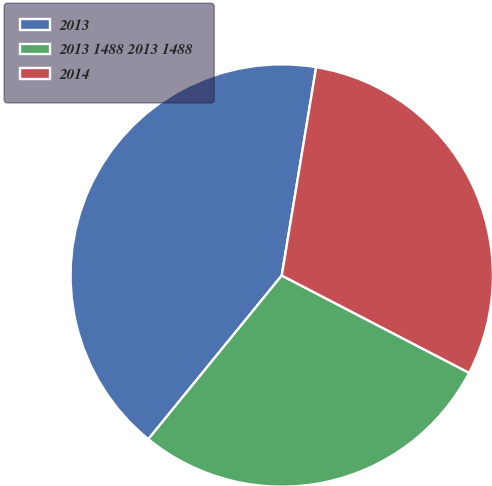Convert chart. <chart><loc_0><loc_0><loc_500><loc_500><pie_chart><fcel>2013<fcel>2013 1488 2013 1488<fcel>2014<nl><fcel>41.72%<fcel>28.26%<fcel>30.02%<nl></chart> 